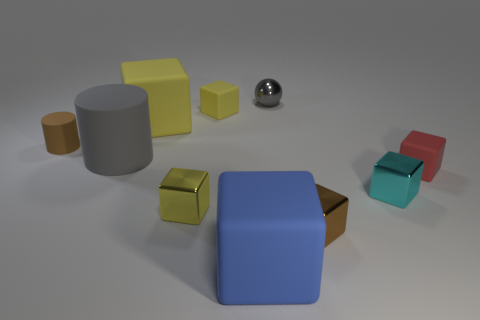Is there a small purple shiny object that has the same shape as the tiny brown metal object?
Offer a terse response. No. Are there more shiny blocks to the right of the tiny gray metal ball than gray rubber cylinders?
Keep it short and to the point. Yes. What number of rubber things are tiny objects or small brown cubes?
Offer a terse response. 3. How big is the matte object that is on the left side of the big yellow matte thing and on the right side of the small rubber cylinder?
Ensure brevity in your answer.  Large. Are there any small matte blocks that are behind the large cube that is behind the tiny red matte object?
Keep it short and to the point. Yes. There is a tiny red matte cube; what number of large blue matte blocks are to the right of it?
Offer a terse response. 0. There is another tiny rubber thing that is the same shape as the red rubber object; what color is it?
Offer a terse response. Yellow. Is the small yellow cube that is to the left of the tiny yellow matte thing made of the same material as the cube behind the big yellow block?
Give a very brief answer. No. There is a big matte cylinder; is its color the same as the tiny shiny object behind the big rubber cylinder?
Give a very brief answer. Yes. What shape is the metal object that is both to the right of the blue matte block and to the left of the brown metallic object?
Your answer should be very brief. Sphere. 